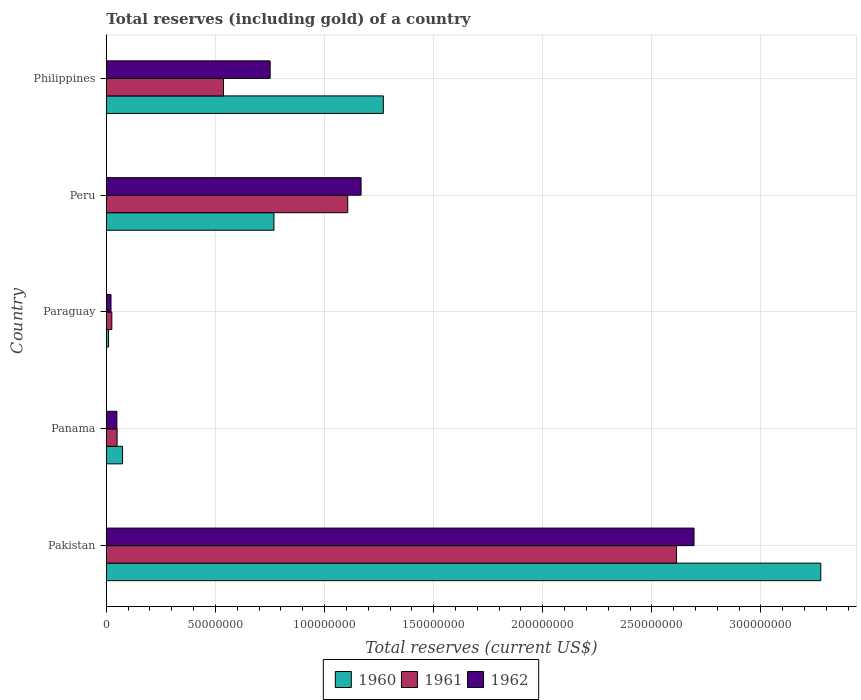How many different coloured bars are there?
Keep it short and to the point. 3. How many groups of bars are there?
Give a very brief answer. 5. How many bars are there on the 4th tick from the top?
Ensure brevity in your answer.  3. How many bars are there on the 1st tick from the bottom?
Your answer should be very brief. 3. What is the label of the 2nd group of bars from the top?
Make the answer very short. Peru. What is the total reserves (including gold) in 1960 in Philippines?
Your answer should be compact. 1.27e+08. Across all countries, what is the maximum total reserves (including gold) in 1962?
Your answer should be compact. 2.69e+08. Across all countries, what is the minimum total reserves (including gold) in 1961?
Your answer should be compact. 2.52e+06. In which country was the total reserves (including gold) in 1962 maximum?
Keep it short and to the point. Pakistan. In which country was the total reserves (including gold) in 1960 minimum?
Ensure brevity in your answer.  Paraguay. What is the total total reserves (including gold) in 1961 in the graph?
Your response must be concise. 4.33e+08. What is the difference between the total reserves (including gold) in 1962 in Panama and that in Paraguay?
Your answer should be very brief. 2.69e+06. What is the difference between the total reserves (including gold) in 1962 in Panama and the total reserves (including gold) in 1961 in Paraguay?
Your answer should be very brief. 2.31e+06. What is the average total reserves (including gold) in 1962 per country?
Your response must be concise. 9.36e+07. What is the difference between the total reserves (including gold) in 1962 and total reserves (including gold) in 1961 in Panama?
Make the answer very short. -1.00e+05. In how many countries, is the total reserves (including gold) in 1962 greater than 300000000 US$?
Offer a terse response. 0. What is the ratio of the total reserves (including gold) in 1961 in Pakistan to that in Philippines?
Your answer should be very brief. 4.87. Is the total reserves (including gold) in 1962 in Paraguay less than that in Philippines?
Provide a succinct answer. Yes. What is the difference between the highest and the second highest total reserves (including gold) in 1961?
Ensure brevity in your answer.  1.51e+08. What is the difference between the highest and the lowest total reserves (including gold) in 1962?
Your answer should be very brief. 2.67e+08. In how many countries, is the total reserves (including gold) in 1960 greater than the average total reserves (including gold) in 1960 taken over all countries?
Your response must be concise. 2. Is it the case that in every country, the sum of the total reserves (including gold) in 1960 and total reserves (including gold) in 1962 is greater than the total reserves (including gold) in 1961?
Your answer should be compact. Yes. How many bars are there?
Ensure brevity in your answer.  15. Are all the bars in the graph horizontal?
Offer a terse response. Yes. Are the values on the major ticks of X-axis written in scientific E-notation?
Your answer should be very brief. No. Does the graph contain grids?
Offer a terse response. Yes. Where does the legend appear in the graph?
Offer a terse response. Bottom center. What is the title of the graph?
Keep it short and to the point. Total reserves (including gold) of a country. Does "2011" appear as one of the legend labels in the graph?
Your answer should be very brief. No. What is the label or title of the X-axis?
Give a very brief answer. Total reserves (current US$). What is the Total reserves (current US$) in 1960 in Pakistan?
Provide a succinct answer. 3.27e+08. What is the Total reserves (current US$) in 1961 in Pakistan?
Give a very brief answer. 2.61e+08. What is the Total reserves (current US$) in 1962 in Pakistan?
Ensure brevity in your answer.  2.69e+08. What is the Total reserves (current US$) in 1960 in Panama?
Your answer should be compact. 7.43e+06. What is the Total reserves (current US$) in 1961 in Panama?
Your response must be concise. 4.93e+06. What is the Total reserves (current US$) in 1962 in Panama?
Your answer should be very brief. 4.83e+06. What is the Total reserves (current US$) in 1960 in Paraguay?
Ensure brevity in your answer.  1.01e+06. What is the Total reserves (current US$) in 1961 in Paraguay?
Give a very brief answer. 2.52e+06. What is the Total reserves (current US$) of 1962 in Paraguay?
Your answer should be compact. 2.14e+06. What is the Total reserves (current US$) in 1960 in Peru?
Keep it short and to the point. 7.68e+07. What is the Total reserves (current US$) of 1961 in Peru?
Make the answer very short. 1.11e+08. What is the Total reserves (current US$) of 1962 in Peru?
Ensure brevity in your answer.  1.17e+08. What is the Total reserves (current US$) of 1960 in Philippines?
Offer a very short reply. 1.27e+08. What is the Total reserves (current US$) of 1961 in Philippines?
Your answer should be compact. 5.37e+07. What is the Total reserves (current US$) in 1962 in Philippines?
Make the answer very short. 7.51e+07. Across all countries, what is the maximum Total reserves (current US$) of 1960?
Keep it short and to the point. 3.27e+08. Across all countries, what is the maximum Total reserves (current US$) in 1961?
Provide a succinct answer. 2.61e+08. Across all countries, what is the maximum Total reserves (current US$) in 1962?
Provide a succinct answer. 2.69e+08. Across all countries, what is the minimum Total reserves (current US$) of 1960?
Your answer should be compact. 1.01e+06. Across all countries, what is the minimum Total reserves (current US$) of 1961?
Ensure brevity in your answer.  2.52e+06. Across all countries, what is the minimum Total reserves (current US$) in 1962?
Keep it short and to the point. 2.14e+06. What is the total Total reserves (current US$) in 1960 in the graph?
Your answer should be compact. 5.40e+08. What is the total Total reserves (current US$) of 1961 in the graph?
Offer a terse response. 4.33e+08. What is the total Total reserves (current US$) of 1962 in the graph?
Your response must be concise. 4.68e+08. What is the difference between the Total reserves (current US$) in 1960 in Pakistan and that in Panama?
Keep it short and to the point. 3.20e+08. What is the difference between the Total reserves (current US$) in 1961 in Pakistan and that in Panama?
Your answer should be compact. 2.56e+08. What is the difference between the Total reserves (current US$) in 1962 in Pakistan and that in Panama?
Offer a terse response. 2.64e+08. What is the difference between the Total reserves (current US$) of 1960 in Pakistan and that in Paraguay?
Your answer should be very brief. 3.26e+08. What is the difference between the Total reserves (current US$) of 1961 in Pakistan and that in Paraguay?
Offer a very short reply. 2.59e+08. What is the difference between the Total reserves (current US$) in 1962 in Pakistan and that in Paraguay?
Provide a short and direct response. 2.67e+08. What is the difference between the Total reserves (current US$) of 1960 in Pakistan and that in Peru?
Give a very brief answer. 2.51e+08. What is the difference between the Total reserves (current US$) of 1961 in Pakistan and that in Peru?
Offer a terse response. 1.51e+08. What is the difference between the Total reserves (current US$) in 1962 in Pakistan and that in Peru?
Keep it short and to the point. 1.53e+08. What is the difference between the Total reserves (current US$) in 1960 in Pakistan and that in Philippines?
Offer a terse response. 2.00e+08. What is the difference between the Total reserves (current US$) in 1961 in Pakistan and that in Philippines?
Provide a short and direct response. 2.08e+08. What is the difference between the Total reserves (current US$) of 1962 in Pakistan and that in Philippines?
Offer a very short reply. 1.94e+08. What is the difference between the Total reserves (current US$) of 1960 in Panama and that in Paraguay?
Your response must be concise. 6.42e+06. What is the difference between the Total reserves (current US$) of 1961 in Panama and that in Paraguay?
Your response must be concise. 2.41e+06. What is the difference between the Total reserves (current US$) in 1962 in Panama and that in Paraguay?
Your answer should be very brief. 2.69e+06. What is the difference between the Total reserves (current US$) of 1960 in Panama and that in Peru?
Your answer should be compact. -6.94e+07. What is the difference between the Total reserves (current US$) of 1961 in Panama and that in Peru?
Ensure brevity in your answer.  -1.06e+08. What is the difference between the Total reserves (current US$) in 1962 in Panama and that in Peru?
Your answer should be very brief. -1.12e+08. What is the difference between the Total reserves (current US$) in 1960 in Panama and that in Philippines?
Ensure brevity in your answer.  -1.20e+08. What is the difference between the Total reserves (current US$) in 1961 in Panama and that in Philippines?
Offer a terse response. -4.88e+07. What is the difference between the Total reserves (current US$) in 1962 in Panama and that in Philippines?
Provide a short and direct response. -7.02e+07. What is the difference between the Total reserves (current US$) of 1960 in Paraguay and that in Peru?
Offer a terse response. -7.58e+07. What is the difference between the Total reserves (current US$) in 1961 in Paraguay and that in Peru?
Offer a terse response. -1.08e+08. What is the difference between the Total reserves (current US$) of 1962 in Paraguay and that in Peru?
Your answer should be compact. -1.15e+08. What is the difference between the Total reserves (current US$) in 1960 in Paraguay and that in Philippines?
Ensure brevity in your answer.  -1.26e+08. What is the difference between the Total reserves (current US$) in 1961 in Paraguay and that in Philippines?
Your response must be concise. -5.12e+07. What is the difference between the Total reserves (current US$) of 1962 in Paraguay and that in Philippines?
Your answer should be compact. -7.29e+07. What is the difference between the Total reserves (current US$) in 1960 in Peru and that in Philippines?
Keep it short and to the point. -5.01e+07. What is the difference between the Total reserves (current US$) of 1961 in Peru and that in Philippines?
Offer a very short reply. 5.69e+07. What is the difference between the Total reserves (current US$) in 1962 in Peru and that in Philippines?
Your response must be concise. 4.17e+07. What is the difference between the Total reserves (current US$) in 1960 in Pakistan and the Total reserves (current US$) in 1961 in Panama?
Your answer should be compact. 3.22e+08. What is the difference between the Total reserves (current US$) of 1960 in Pakistan and the Total reserves (current US$) of 1962 in Panama?
Offer a very short reply. 3.23e+08. What is the difference between the Total reserves (current US$) in 1961 in Pakistan and the Total reserves (current US$) in 1962 in Panama?
Offer a terse response. 2.56e+08. What is the difference between the Total reserves (current US$) of 1960 in Pakistan and the Total reserves (current US$) of 1961 in Paraguay?
Offer a terse response. 3.25e+08. What is the difference between the Total reserves (current US$) in 1960 in Pakistan and the Total reserves (current US$) in 1962 in Paraguay?
Your answer should be compact. 3.25e+08. What is the difference between the Total reserves (current US$) of 1961 in Pakistan and the Total reserves (current US$) of 1962 in Paraguay?
Offer a terse response. 2.59e+08. What is the difference between the Total reserves (current US$) in 1960 in Pakistan and the Total reserves (current US$) in 1961 in Peru?
Provide a short and direct response. 2.17e+08. What is the difference between the Total reserves (current US$) of 1960 in Pakistan and the Total reserves (current US$) of 1962 in Peru?
Make the answer very short. 2.11e+08. What is the difference between the Total reserves (current US$) in 1961 in Pakistan and the Total reserves (current US$) in 1962 in Peru?
Offer a terse response. 1.45e+08. What is the difference between the Total reserves (current US$) of 1960 in Pakistan and the Total reserves (current US$) of 1961 in Philippines?
Provide a succinct answer. 2.74e+08. What is the difference between the Total reserves (current US$) of 1960 in Pakistan and the Total reserves (current US$) of 1962 in Philippines?
Your answer should be compact. 2.52e+08. What is the difference between the Total reserves (current US$) in 1961 in Pakistan and the Total reserves (current US$) in 1962 in Philippines?
Offer a terse response. 1.86e+08. What is the difference between the Total reserves (current US$) in 1960 in Panama and the Total reserves (current US$) in 1961 in Paraguay?
Your answer should be very brief. 4.91e+06. What is the difference between the Total reserves (current US$) of 1960 in Panama and the Total reserves (current US$) of 1962 in Paraguay?
Ensure brevity in your answer.  5.29e+06. What is the difference between the Total reserves (current US$) in 1961 in Panama and the Total reserves (current US$) in 1962 in Paraguay?
Your answer should be very brief. 2.79e+06. What is the difference between the Total reserves (current US$) in 1960 in Panama and the Total reserves (current US$) in 1961 in Peru?
Keep it short and to the point. -1.03e+08. What is the difference between the Total reserves (current US$) in 1960 in Panama and the Total reserves (current US$) in 1962 in Peru?
Your response must be concise. -1.09e+08. What is the difference between the Total reserves (current US$) of 1961 in Panama and the Total reserves (current US$) of 1962 in Peru?
Ensure brevity in your answer.  -1.12e+08. What is the difference between the Total reserves (current US$) in 1960 in Panama and the Total reserves (current US$) in 1961 in Philippines?
Offer a very short reply. -4.63e+07. What is the difference between the Total reserves (current US$) in 1960 in Panama and the Total reserves (current US$) in 1962 in Philippines?
Ensure brevity in your answer.  -6.76e+07. What is the difference between the Total reserves (current US$) in 1961 in Panama and the Total reserves (current US$) in 1962 in Philippines?
Keep it short and to the point. -7.01e+07. What is the difference between the Total reserves (current US$) in 1960 in Paraguay and the Total reserves (current US$) in 1961 in Peru?
Your answer should be very brief. -1.10e+08. What is the difference between the Total reserves (current US$) of 1960 in Paraguay and the Total reserves (current US$) of 1962 in Peru?
Offer a terse response. -1.16e+08. What is the difference between the Total reserves (current US$) of 1961 in Paraguay and the Total reserves (current US$) of 1962 in Peru?
Give a very brief answer. -1.14e+08. What is the difference between the Total reserves (current US$) of 1960 in Paraguay and the Total reserves (current US$) of 1961 in Philippines?
Provide a short and direct response. -5.27e+07. What is the difference between the Total reserves (current US$) of 1960 in Paraguay and the Total reserves (current US$) of 1962 in Philippines?
Your answer should be very brief. -7.41e+07. What is the difference between the Total reserves (current US$) of 1961 in Paraguay and the Total reserves (current US$) of 1962 in Philippines?
Provide a short and direct response. -7.25e+07. What is the difference between the Total reserves (current US$) in 1960 in Peru and the Total reserves (current US$) in 1961 in Philippines?
Your response must be concise. 2.31e+07. What is the difference between the Total reserves (current US$) in 1960 in Peru and the Total reserves (current US$) in 1962 in Philippines?
Make the answer very short. 1.74e+06. What is the difference between the Total reserves (current US$) of 1961 in Peru and the Total reserves (current US$) of 1962 in Philippines?
Offer a terse response. 3.56e+07. What is the average Total reserves (current US$) in 1960 per country?
Give a very brief answer. 1.08e+08. What is the average Total reserves (current US$) in 1961 per country?
Your answer should be very brief. 8.66e+07. What is the average Total reserves (current US$) of 1962 per country?
Make the answer very short. 9.36e+07. What is the difference between the Total reserves (current US$) of 1960 and Total reserves (current US$) of 1961 in Pakistan?
Your answer should be very brief. 6.61e+07. What is the difference between the Total reserves (current US$) in 1960 and Total reserves (current US$) in 1962 in Pakistan?
Give a very brief answer. 5.81e+07. What is the difference between the Total reserves (current US$) in 1961 and Total reserves (current US$) in 1962 in Pakistan?
Make the answer very short. -8.01e+06. What is the difference between the Total reserves (current US$) of 1960 and Total reserves (current US$) of 1961 in Panama?
Give a very brief answer. 2.50e+06. What is the difference between the Total reserves (current US$) in 1960 and Total reserves (current US$) in 1962 in Panama?
Offer a terse response. 2.60e+06. What is the difference between the Total reserves (current US$) in 1960 and Total reserves (current US$) in 1961 in Paraguay?
Offer a terse response. -1.51e+06. What is the difference between the Total reserves (current US$) in 1960 and Total reserves (current US$) in 1962 in Paraguay?
Offer a terse response. -1.13e+06. What is the difference between the Total reserves (current US$) in 1961 and Total reserves (current US$) in 1962 in Paraguay?
Your answer should be compact. 3.80e+05. What is the difference between the Total reserves (current US$) in 1960 and Total reserves (current US$) in 1961 in Peru?
Keep it short and to the point. -3.38e+07. What is the difference between the Total reserves (current US$) in 1960 and Total reserves (current US$) in 1962 in Peru?
Your answer should be very brief. -3.99e+07. What is the difference between the Total reserves (current US$) in 1961 and Total reserves (current US$) in 1962 in Peru?
Offer a terse response. -6.11e+06. What is the difference between the Total reserves (current US$) in 1960 and Total reserves (current US$) in 1961 in Philippines?
Keep it short and to the point. 7.33e+07. What is the difference between the Total reserves (current US$) of 1960 and Total reserves (current US$) of 1962 in Philippines?
Your response must be concise. 5.19e+07. What is the difference between the Total reserves (current US$) in 1961 and Total reserves (current US$) in 1962 in Philippines?
Your answer should be compact. -2.14e+07. What is the ratio of the Total reserves (current US$) in 1960 in Pakistan to that in Panama?
Provide a succinct answer. 44.06. What is the ratio of the Total reserves (current US$) of 1961 in Pakistan to that in Panama?
Provide a succinct answer. 53. What is the ratio of the Total reserves (current US$) in 1962 in Pakistan to that in Panama?
Your answer should be very brief. 55.76. What is the ratio of the Total reserves (current US$) of 1960 in Pakistan to that in Paraguay?
Keep it short and to the point. 323.61. What is the ratio of the Total reserves (current US$) in 1961 in Pakistan to that in Paraguay?
Make the answer very short. 103.68. What is the ratio of the Total reserves (current US$) in 1962 in Pakistan to that in Paraguay?
Provide a succinct answer. 125.84. What is the ratio of the Total reserves (current US$) of 1960 in Pakistan to that in Peru?
Your answer should be very brief. 4.26. What is the ratio of the Total reserves (current US$) of 1961 in Pakistan to that in Peru?
Offer a very short reply. 2.36. What is the ratio of the Total reserves (current US$) of 1962 in Pakistan to that in Peru?
Offer a very short reply. 2.31. What is the ratio of the Total reserves (current US$) in 1960 in Pakistan to that in Philippines?
Offer a terse response. 2.58. What is the ratio of the Total reserves (current US$) in 1961 in Pakistan to that in Philippines?
Offer a terse response. 4.87. What is the ratio of the Total reserves (current US$) of 1962 in Pakistan to that in Philippines?
Keep it short and to the point. 3.59. What is the ratio of the Total reserves (current US$) in 1960 in Panama to that in Paraguay?
Provide a succinct answer. 7.34. What is the ratio of the Total reserves (current US$) of 1961 in Panama to that in Paraguay?
Offer a very short reply. 1.96. What is the ratio of the Total reserves (current US$) of 1962 in Panama to that in Paraguay?
Your answer should be very brief. 2.26. What is the ratio of the Total reserves (current US$) of 1960 in Panama to that in Peru?
Provide a succinct answer. 0.1. What is the ratio of the Total reserves (current US$) in 1961 in Panama to that in Peru?
Give a very brief answer. 0.04. What is the ratio of the Total reserves (current US$) in 1962 in Panama to that in Peru?
Your answer should be compact. 0.04. What is the ratio of the Total reserves (current US$) in 1960 in Panama to that in Philippines?
Make the answer very short. 0.06. What is the ratio of the Total reserves (current US$) of 1961 in Panama to that in Philippines?
Your answer should be compact. 0.09. What is the ratio of the Total reserves (current US$) of 1962 in Panama to that in Philippines?
Your response must be concise. 0.06. What is the ratio of the Total reserves (current US$) of 1960 in Paraguay to that in Peru?
Give a very brief answer. 0.01. What is the ratio of the Total reserves (current US$) of 1961 in Paraguay to that in Peru?
Your response must be concise. 0.02. What is the ratio of the Total reserves (current US$) in 1962 in Paraguay to that in Peru?
Make the answer very short. 0.02. What is the ratio of the Total reserves (current US$) in 1960 in Paraguay to that in Philippines?
Keep it short and to the point. 0.01. What is the ratio of the Total reserves (current US$) of 1961 in Paraguay to that in Philippines?
Your answer should be compact. 0.05. What is the ratio of the Total reserves (current US$) in 1962 in Paraguay to that in Philippines?
Provide a succinct answer. 0.03. What is the ratio of the Total reserves (current US$) of 1960 in Peru to that in Philippines?
Offer a very short reply. 0.61. What is the ratio of the Total reserves (current US$) in 1961 in Peru to that in Philippines?
Offer a very short reply. 2.06. What is the ratio of the Total reserves (current US$) of 1962 in Peru to that in Philippines?
Offer a terse response. 1.56. What is the difference between the highest and the second highest Total reserves (current US$) in 1960?
Provide a succinct answer. 2.00e+08. What is the difference between the highest and the second highest Total reserves (current US$) of 1961?
Your response must be concise. 1.51e+08. What is the difference between the highest and the second highest Total reserves (current US$) of 1962?
Ensure brevity in your answer.  1.53e+08. What is the difference between the highest and the lowest Total reserves (current US$) of 1960?
Your response must be concise. 3.26e+08. What is the difference between the highest and the lowest Total reserves (current US$) in 1961?
Offer a terse response. 2.59e+08. What is the difference between the highest and the lowest Total reserves (current US$) in 1962?
Your answer should be compact. 2.67e+08. 